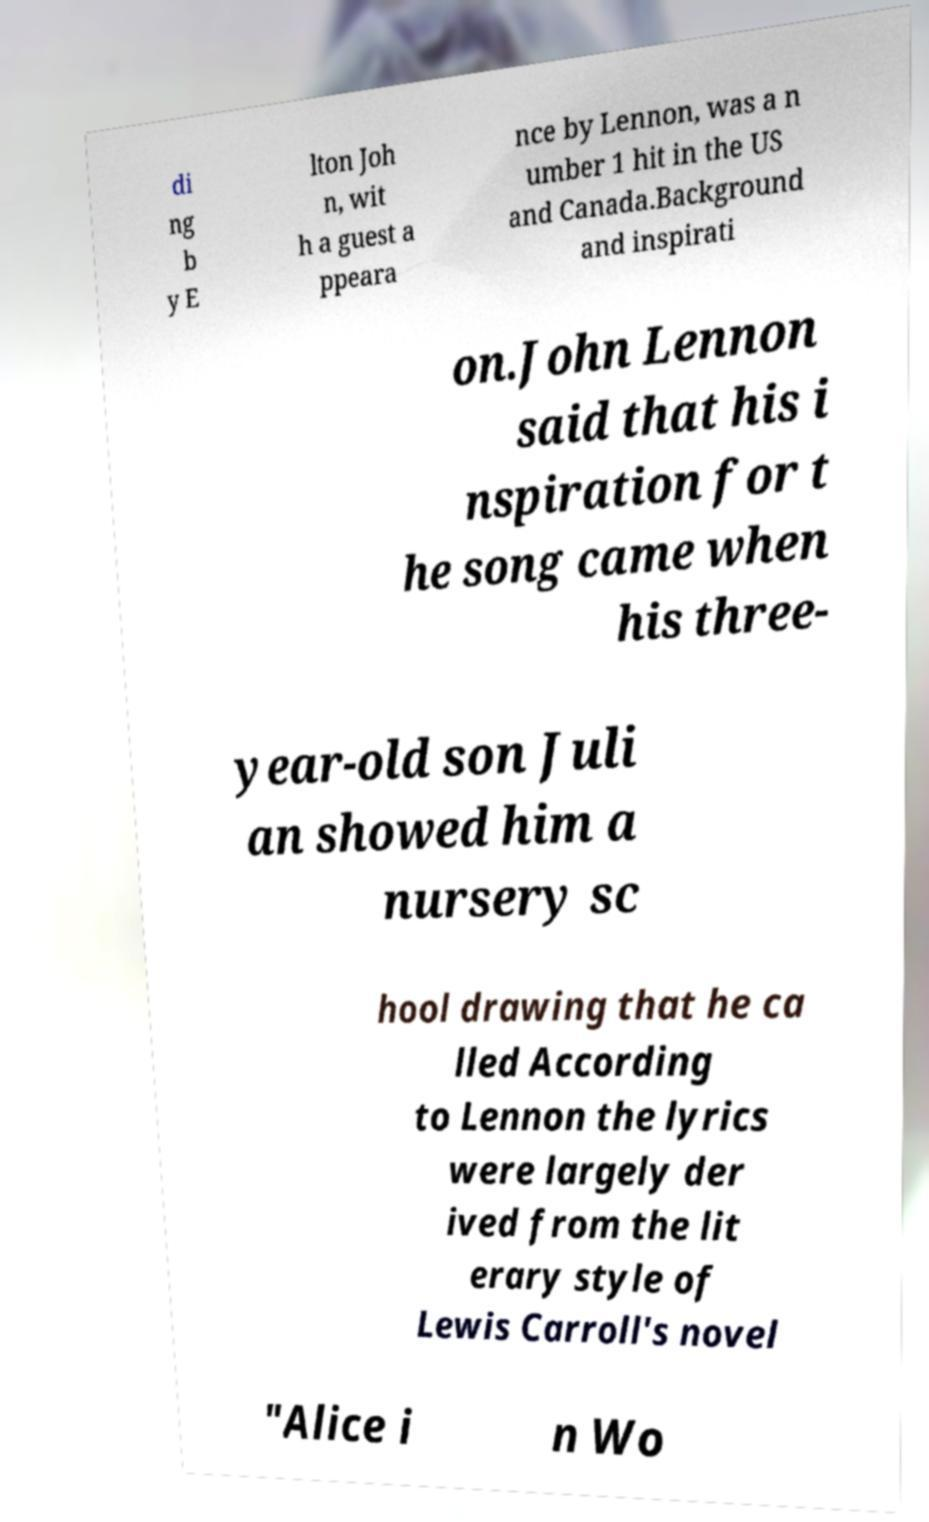Could you extract and type out the text from this image? di ng b y E lton Joh n, wit h a guest a ppeara nce by Lennon, was a n umber 1 hit in the US and Canada.Background and inspirati on.John Lennon said that his i nspiration for t he song came when his three- year-old son Juli an showed him a nursery sc hool drawing that he ca lled According to Lennon the lyrics were largely der ived from the lit erary style of Lewis Carroll's novel "Alice i n Wo 